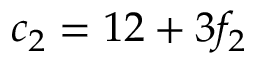<formula> <loc_0><loc_0><loc_500><loc_500>c _ { 2 } = 1 2 + 3 f _ { 2 }</formula> 